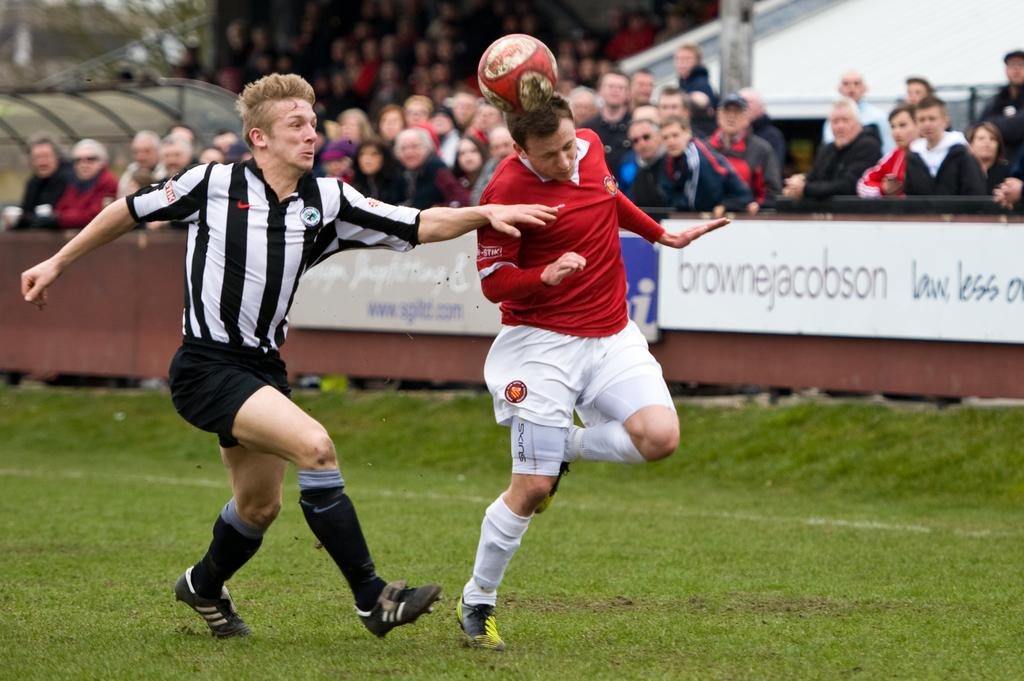What are the two people in the image doing? The two people in the image are running. On what surface are the people running? The people are running on a ground. What object is present in the image besides the people? There is a ball in the image. What are the people in the background doing? The people in the background are standing and watching a game. What is the purpose of the railing in the image? The railing is likely there to separate the spectators from the area where the game is being played. What structure can be seen in the image? There is a wall in the image. What type of butter is being used to grease the wool in the image? There is no butter or wool present in the image; it features two people running, a ball, and people watching a game. 